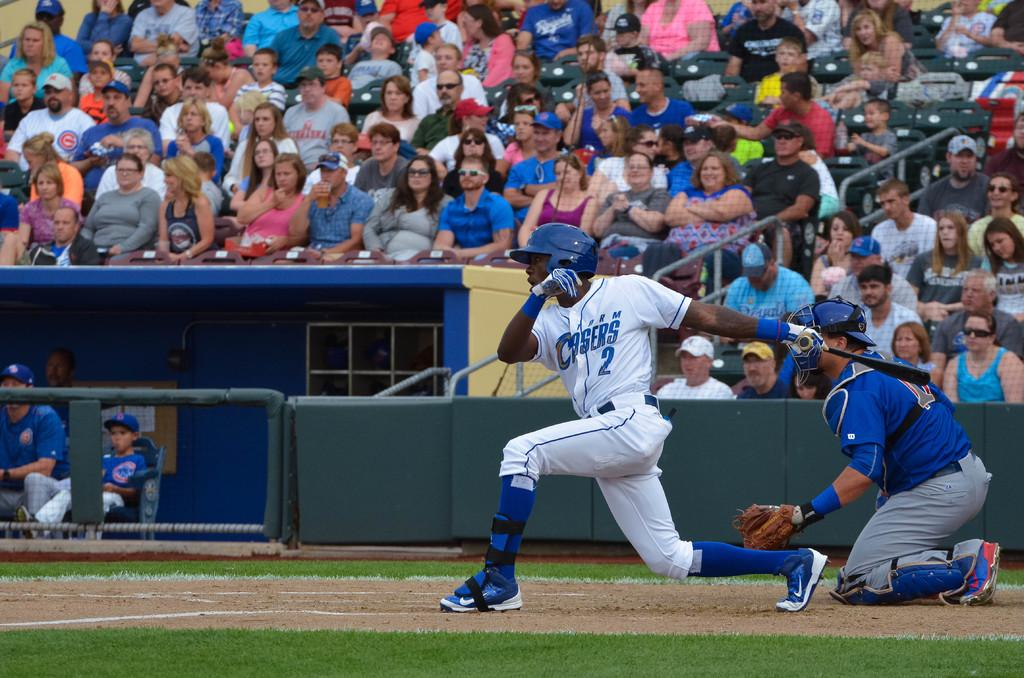Provide a one-sentence caption for the provided image. a baseball player batting in a Storm Chasers 2 jersey. 